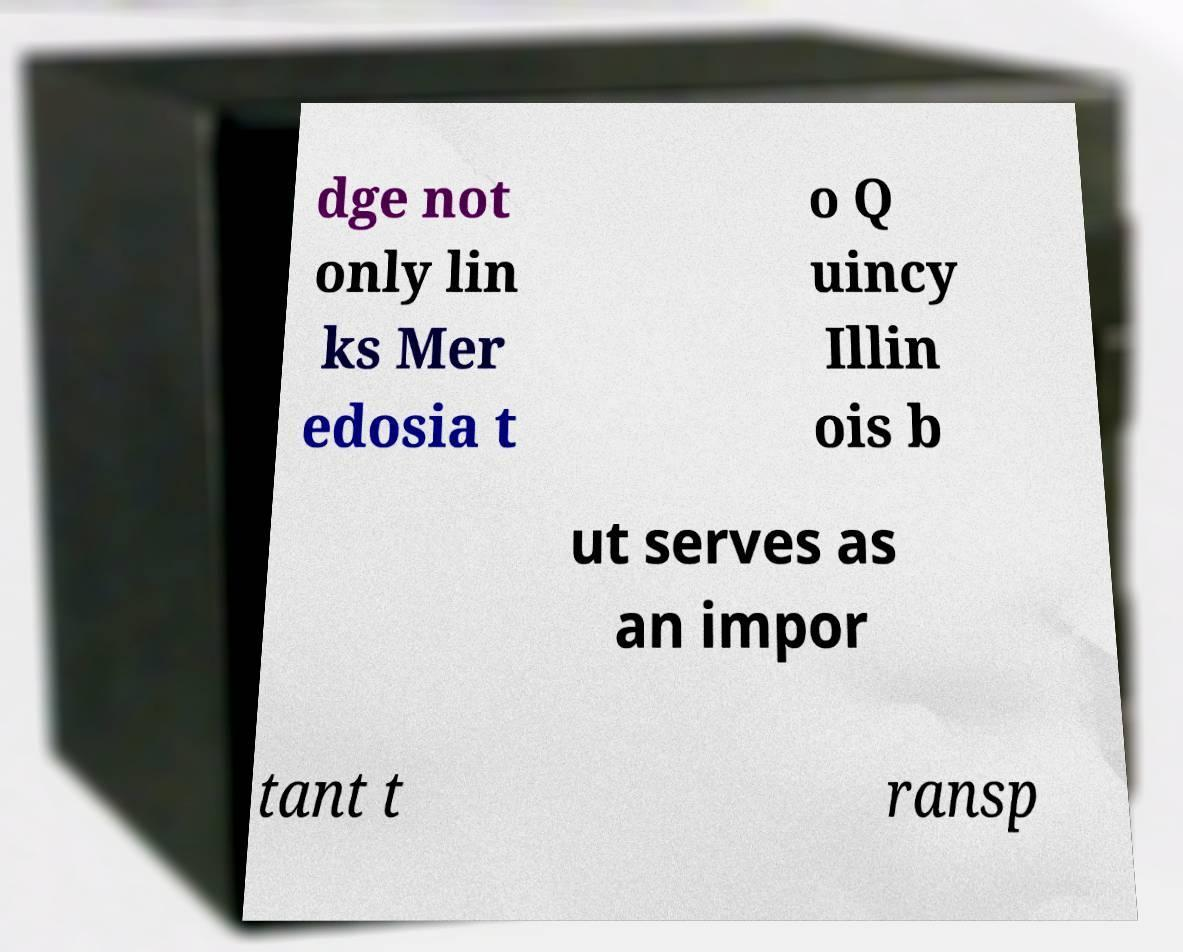What messages or text are displayed in this image? I need them in a readable, typed format. dge not only lin ks Mer edosia t o Q uincy Illin ois b ut serves as an impor tant t ransp 